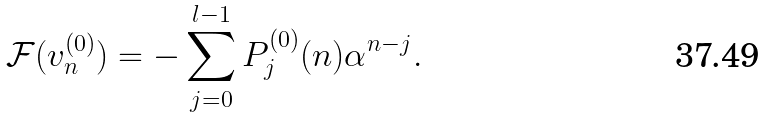<formula> <loc_0><loc_0><loc_500><loc_500>\mathcal { F } ( v _ { n } ^ { ( 0 ) } ) = - \sum _ { j = 0 } ^ { l - 1 } P _ { j } ^ { ( 0 ) } ( n ) \alpha ^ { n - j } .</formula> 